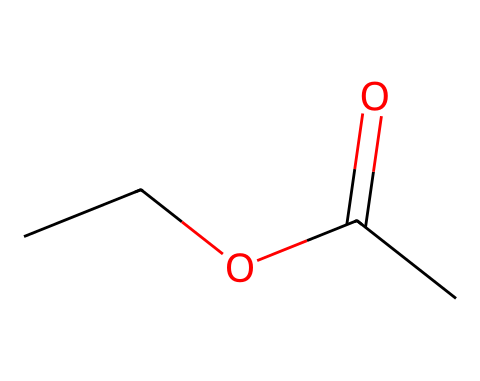What is the molecular formula of this compound? The SMILES representation indicates the presence of two carbon (C) atoms from "CC," two oxygen (O) atoms from "O" and "(=O)," and three hydrogen (H) atoms are implied. Together, this leads to the molecular formula C4H8O2.
Answer: C4H8O2 How many carbon atoms are in ethyl acetate? By analyzing the SMILES "CCOC(=O)C," we note that there are four carbon atoms present: two from "CC," one from the alkoxy part "C," and another from the carbon in "(=O)C."
Answer: 4 What functional groups are present in ethyl acetate? The structure shows an ester functional group indicated by the "C(=O)O" section, and an ethyl group "CC." Combined, this means ethyl acetate contains an ester functional group.
Answer: ester How many oxygen atoms are found in ethyl acetate? From the SMILES representation, we see there are two oxygen atoms: one within the ester functional group "C(=O)" and another attached to the alkyl part "O."
Answer: 2 What type of chemical is ethyl acetate categorized as? Given that ethyl acetate is utilized primarily as a solvent with a structure that contains an ester functional group, it is categorized specifically as a solvent.
Answer: solvent What two types of bonds are present in ethyl acetate? In the molecule, there are single bonds between carbon and hydrogen and an ester linkage which involves a double bond between carbon and oxygen (C=O), indicating both single and double bonds are present in the structure.
Answer: single and double 